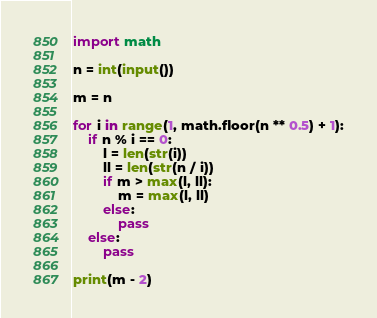Convert code to text. <code><loc_0><loc_0><loc_500><loc_500><_Python_>import math

n = int(input())

m = n

for i in range(1, math.floor(n ** 0.5) + 1):
    if n % i == 0:
        l = len(str(i))
        ll = len(str(n / i)) 
        if m > max(l, ll):
            m = max(l, ll)
        else:
            pass
    else:
        pass

print(m - 2)</code> 